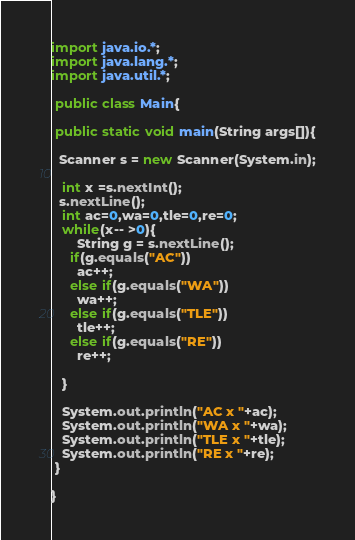Convert code to text. <code><loc_0><loc_0><loc_500><loc_500><_Java_>import java.io.*;
import java.lang.*;
import java.util.*;

 public class Main{
  
 public static void main(String args[]){
   
  Scanner s = new Scanner(System.in);
   
   int x =s.nextInt();
  s.nextLine();
   int ac=0,wa=0,tle=0,re=0;
   while(x-- >0){
       String g = s.nextLine();
     if(g.equals("AC"))
       ac++;
     else if(g.equals("WA"))
       wa++;
     else if(g.equals("TLE"))
       tle++;
     else if(g.equals("RE"))
       re++;
         
   }
   
   System.out.println("AC x "+ac);
   System.out.println("WA x "+wa);
   System.out.println("TLE x "+tle);
   System.out.println("RE x "+re);
 }
  
}</code> 